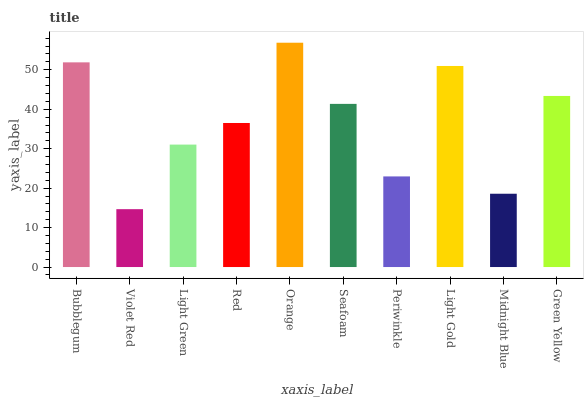Is Violet Red the minimum?
Answer yes or no. Yes. Is Orange the maximum?
Answer yes or no. Yes. Is Light Green the minimum?
Answer yes or no. No. Is Light Green the maximum?
Answer yes or no. No. Is Light Green greater than Violet Red?
Answer yes or no. Yes. Is Violet Red less than Light Green?
Answer yes or no. Yes. Is Violet Red greater than Light Green?
Answer yes or no. No. Is Light Green less than Violet Red?
Answer yes or no. No. Is Seafoam the high median?
Answer yes or no. Yes. Is Red the low median?
Answer yes or no. Yes. Is Red the high median?
Answer yes or no. No. Is Light Green the low median?
Answer yes or no. No. 